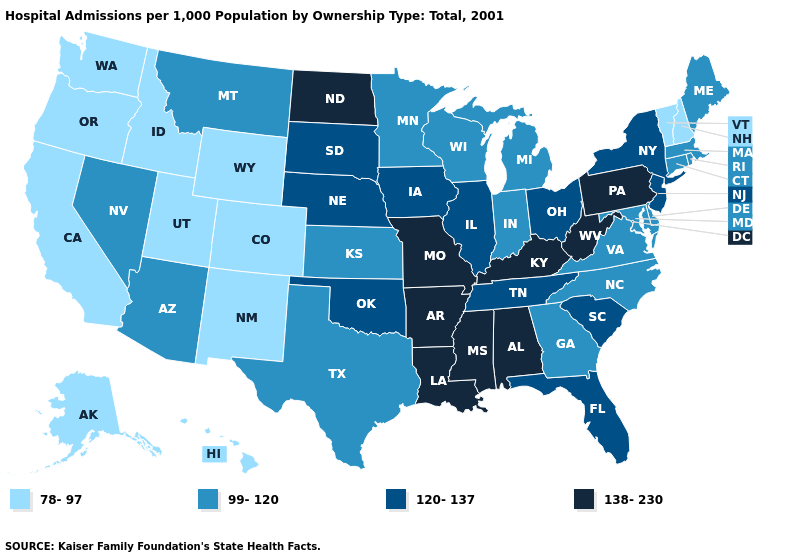Name the states that have a value in the range 138-230?
Write a very short answer. Alabama, Arkansas, Kentucky, Louisiana, Mississippi, Missouri, North Dakota, Pennsylvania, West Virginia. Name the states that have a value in the range 120-137?
Keep it brief. Florida, Illinois, Iowa, Nebraska, New Jersey, New York, Ohio, Oklahoma, South Carolina, South Dakota, Tennessee. What is the value of Nebraska?
Write a very short answer. 120-137. What is the value of New Mexico?
Answer briefly. 78-97. Name the states that have a value in the range 78-97?
Answer briefly. Alaska, California, Colorado, Hawaii, Idaho, New Hampshire, New Mexico, Oregon, Utah, Vermont, Washington, Wyoming. Does Pennsylvania have the highest value in the Northeast?
Short answer required. Yes. Name the states that have a value in the range 138-230?
Give a very brief answer. Alabama, Arkansas, Kentucky, Louisiana, Mississippi, Missouri, North Dakota, Pennsylvania, West Virginia. Does Kentucky have the highest value in the South?
Short answer required. Yes. Name the states that have a value in the range 120-137?
Keep it brief. Florida, Illinois, Iowa, Nebraska, New Jersey, New York, Ohio, Oklahoma, South Carolina, South Dakota, Tennessee. What is the highest value in states that border Wisconsin?
Keep it brief. 120-137. Does the first symbol in the legend represent the smallest category?
Give a very brief answer. Yes. Which states hav the highest value in the Northeast?
Answer briefly. Pennsylvania. Does Maryland have a lower value than Wisconsin?
Concise answer only. No. Which states hav the highest value in the MidWest?
Short answer required. Missouri, North Dakota. Name the states that have a value in the range 99-120?
Short answer required. Arizona, Connecticut, Delaware, Georgia, Indiana, Kansas, Maine, Maryland, Massachusetts, Michigan, Minnesota, Montana, Nevada, North Carolina, Rhode Island, Texas, Virginia, Wisconsin. 